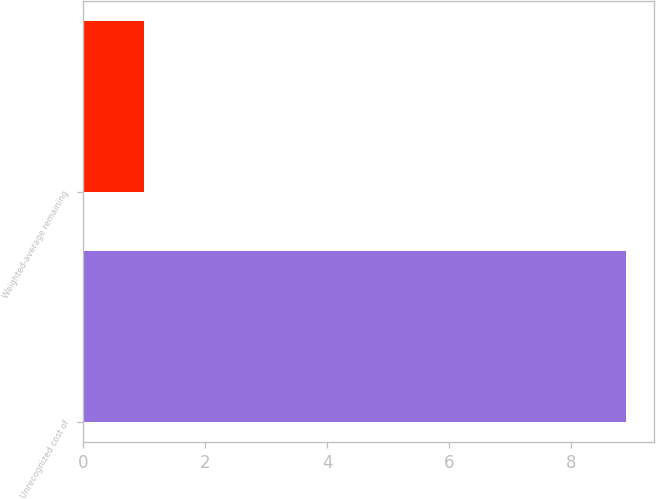Convert chart to OTSL. <chart><loc_0><loc_0><loc_500><loc_500><bar_chart><fcel>Unrecognized cost of<fcel>Weighted-average remaining<nl><fcel>8.9<fcel>1<nl></chart> 